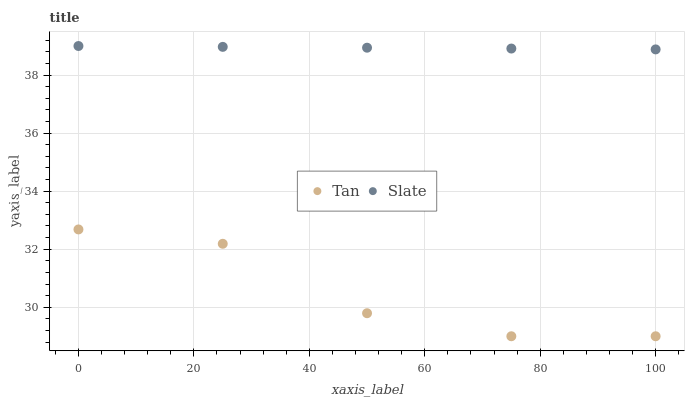Does Tan have the minimum area under the curve?
Answer yes or no. Yes. Does Slate have the maximum area under the curve?
Answer yes or no. Yes. Does Slate have the minimum area under the curve?
Answer yes or no. No. Is Slate the smoothest?
Answer yes or no. Yes. Is Tan the roughest?
Answer yes or no. Yes. Is Slate the roughest?
Answer yes or no. No. Does Tan have the lowest value?
Answer yes or no. Yes. Does Slate have the lowest value?
Answer yes or no. No. Does Slate have the highest value?
Answer yes or no. Yes. Is Tan less than Slate?
Answer yes or no. Yes. Is Slate greater than Tan?
Answer yes or no. Yes. Does Tan intersect Slate?
Answer yes or no. No. 